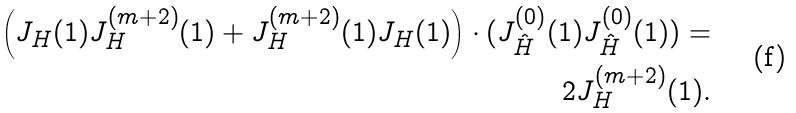Convert formula to latex. <formula><loc_0><loc_0><loc_500><loc_500>\left ( J _ { H } ( 1 ) J ^ { ( m + 2 ) } _ { H } ( 1 ) + J ^ { ( m + 2 ) } _ { H } ( 1 ) J _ { H } ( 1 ) \right ) \cdot ( J ^ { ( 0 ) } _ { \hat { H } } ( 1 ) J ^ { ( 0 ) } _ { \hat { H } } ( 1 ) ) = \\ 2 J ^ { ( m + 2 ) } _ { H } ( 1 ) .</formula> 